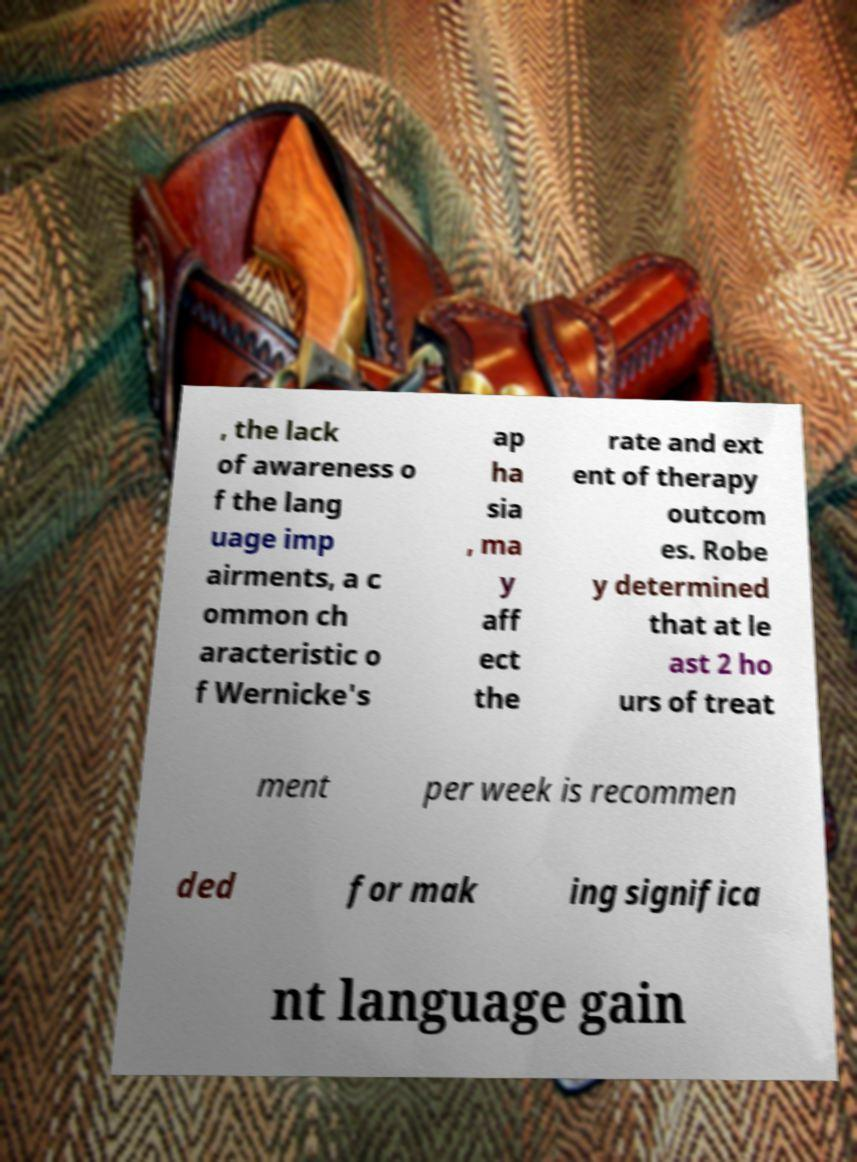Can you accurately transcribe the text from the provided image for me? , the lack of awareness o f the lang uage imp airments, a c ommon ch aracteristic o f Wernicke's ap ha sia , ma y aff ect the rate and ext ent of therapy outcom es. Robe y determined that at le ast 2 ho urs of treat ment per week is recommen ded for mak ing significa nt language gain 